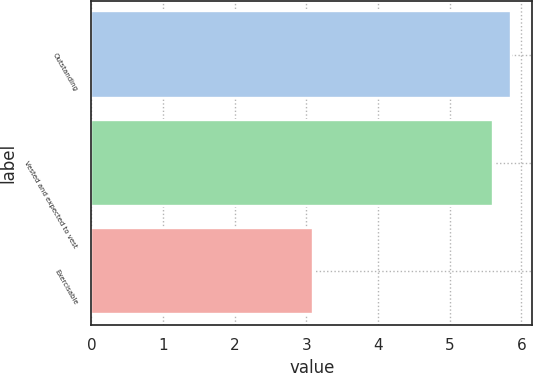<chart> <loc_0><loc_0><loc_500><loc_500><bar_chart><fcel>Outstanding<fcel>Vested and expected to vest<fcel>Exercisable<nl><fcel>5.86<fcel>5.6<fcel>3.1<nl></chart> 